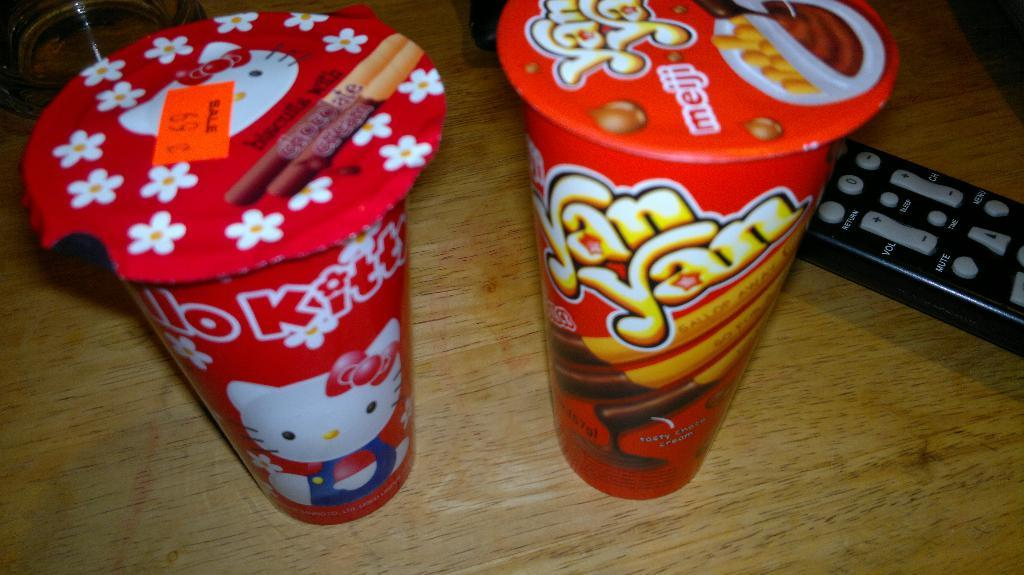Provide a one-sentence caption for the provided image. A package of Hello Kitty biscuits sitting next to a package of YanYans made by Meiji. 